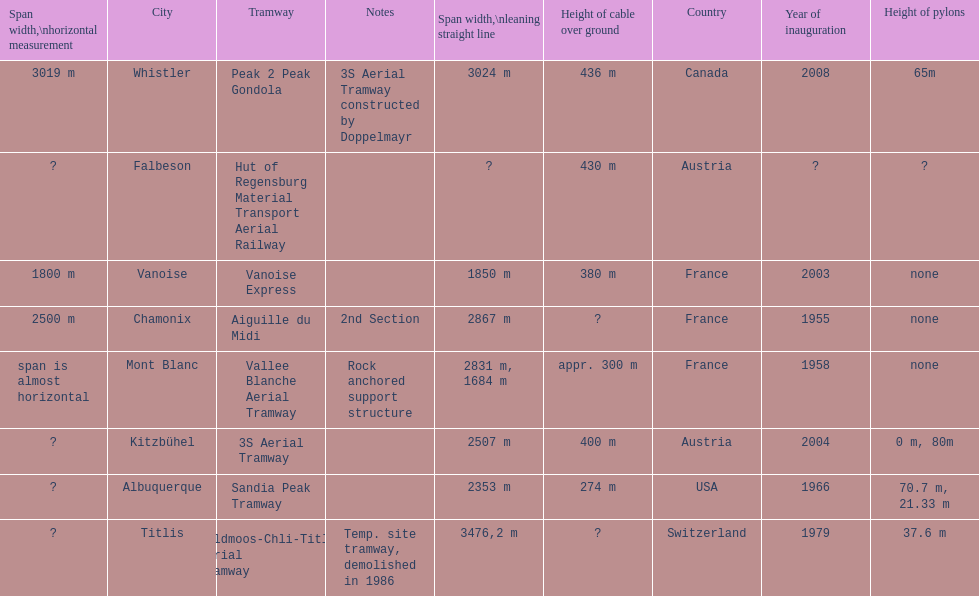Would you mind parsing the complete table? {'header': ['Span width,\\nhorizontal measurement', 'City', 'Tramway', 'Notes', 'Span\xa0width,\\nleaning straight line', 'Height of cable over ground', 'Country', 'Year of inauguration', 'Height of pylons'], 'rows': [['3019 m', 'Whistler', 'Peak 2 Peak Gondola', '3S Aerial Tramway constructed by Doppelmayr', '3024 m', '436 m', 'Canada', '2008', '65m'], ['?', 'Falbeson', 'Hut of Regensburg Material Transport Aerial Railway', '', '?', '430 m', 'Austria', '?', '?'], ['1800 m', 'Vanoise', 'Vanoise Express', '', '1850 m', '380 m', 'France', '2003', 'none'], ['2500 m', 'Chamonix', 'Aiguille du Midi', '2nd Section', '2867 m', '?', 'France', '1955', 'none'], ['span is almost horizontal', 'Mont Blanc', 'Vallee Blanche Aerial Tramway', 'Rock anchored support structure', '2831 m, 1684 m', 'appr. 300 m', 'France', '1958', 'none'], ['?', 'Kitzbühel', '3S Aerial Tramway', '', '2507 m', '400 m', 'Austria', '2004', '0 m, 80m'], ['?', 'Albuquerque', 'Sandia Peak Tramway', '', '2353 m', '274 m', 'USA', '1966', '70.7 m, 21.33 m'], ['?', 'Titlis', 'Feldmoos-Chli-Titlis Aerial Tramway', 'Temp. site tramway, demolished in 1986', '3476,2 m', '?', 'Switzerland', '1979', '37.6 m']]} How much greater is the height of cable over ground measurement for the peak 2 peak gondola when compared with that of the vanoise express? 56 m. 